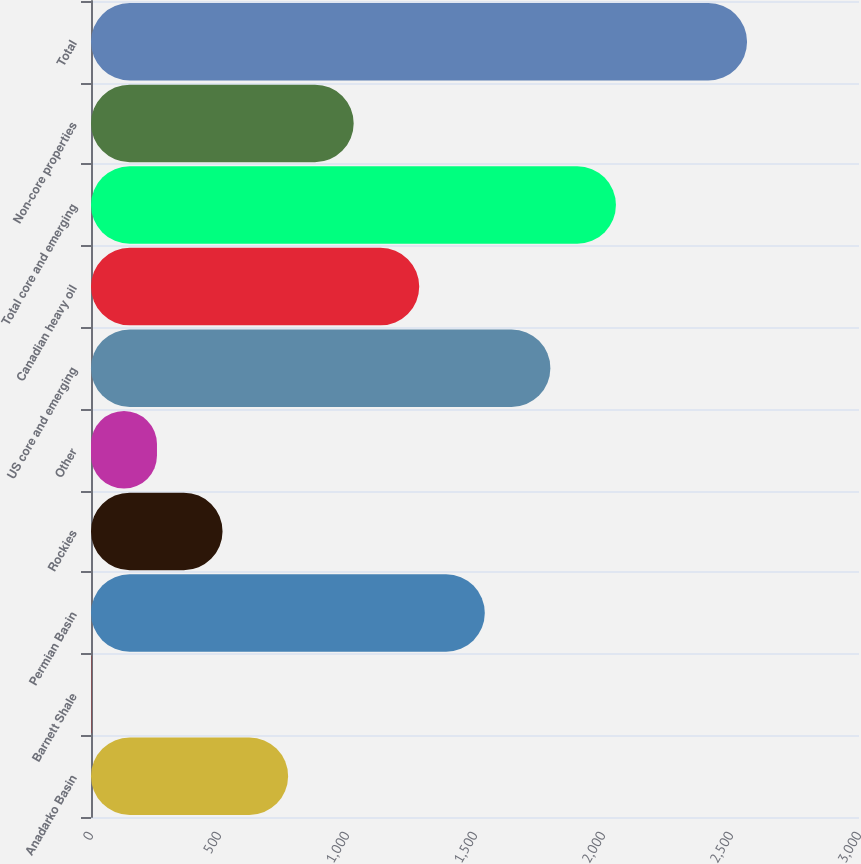Convert chart. <chart><loc_0><loc_0><loc_500><loc_500><bar_chart><fcel>Anadarko Basin<fcel>Barnett Shale<fcel>Permian Basin<fcel>Rockies<fcel>Other<fcel>US core and emerging<fcel>Canadian heavy oil<fcel>Total core and emerging<fcel>Non-core properties<fcel>Total<nl><fcel>769.96<fcel>1.6<fcel>1538.32<fcel>513.84<fcel>257.72<fcel>1794.44<fcel>1282.2<fcel>2050.56<fcel>1026.08<fcel>2562.8<nl></chart> 